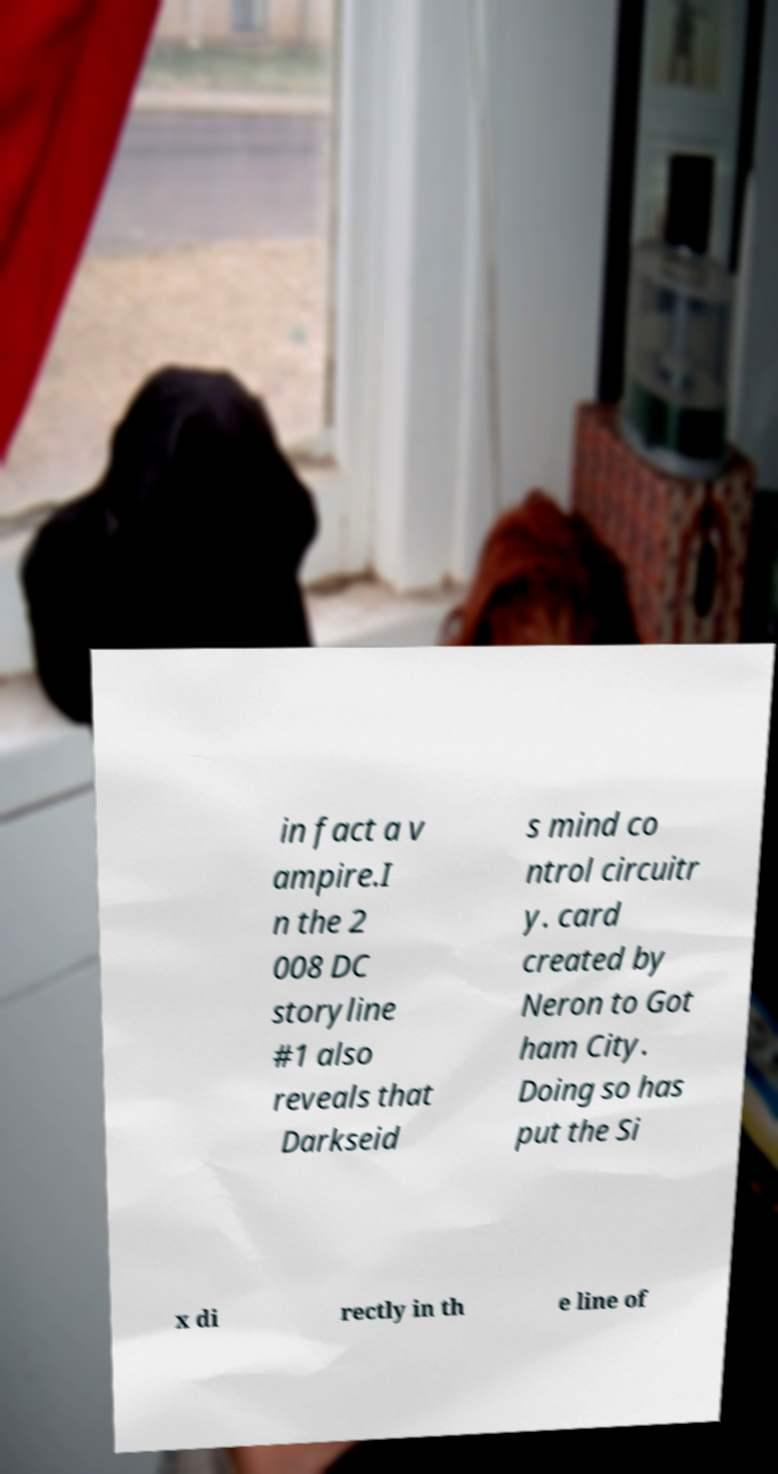Could you extract and type out the text from this image? in fact a v ampire.I n the 2 008 DC storyline #1 also reveals that Darkseid s mind co ntrol circuitr y. card created by Neron to Got ham City. Doing so has put the Si x di rectly in th e line of 